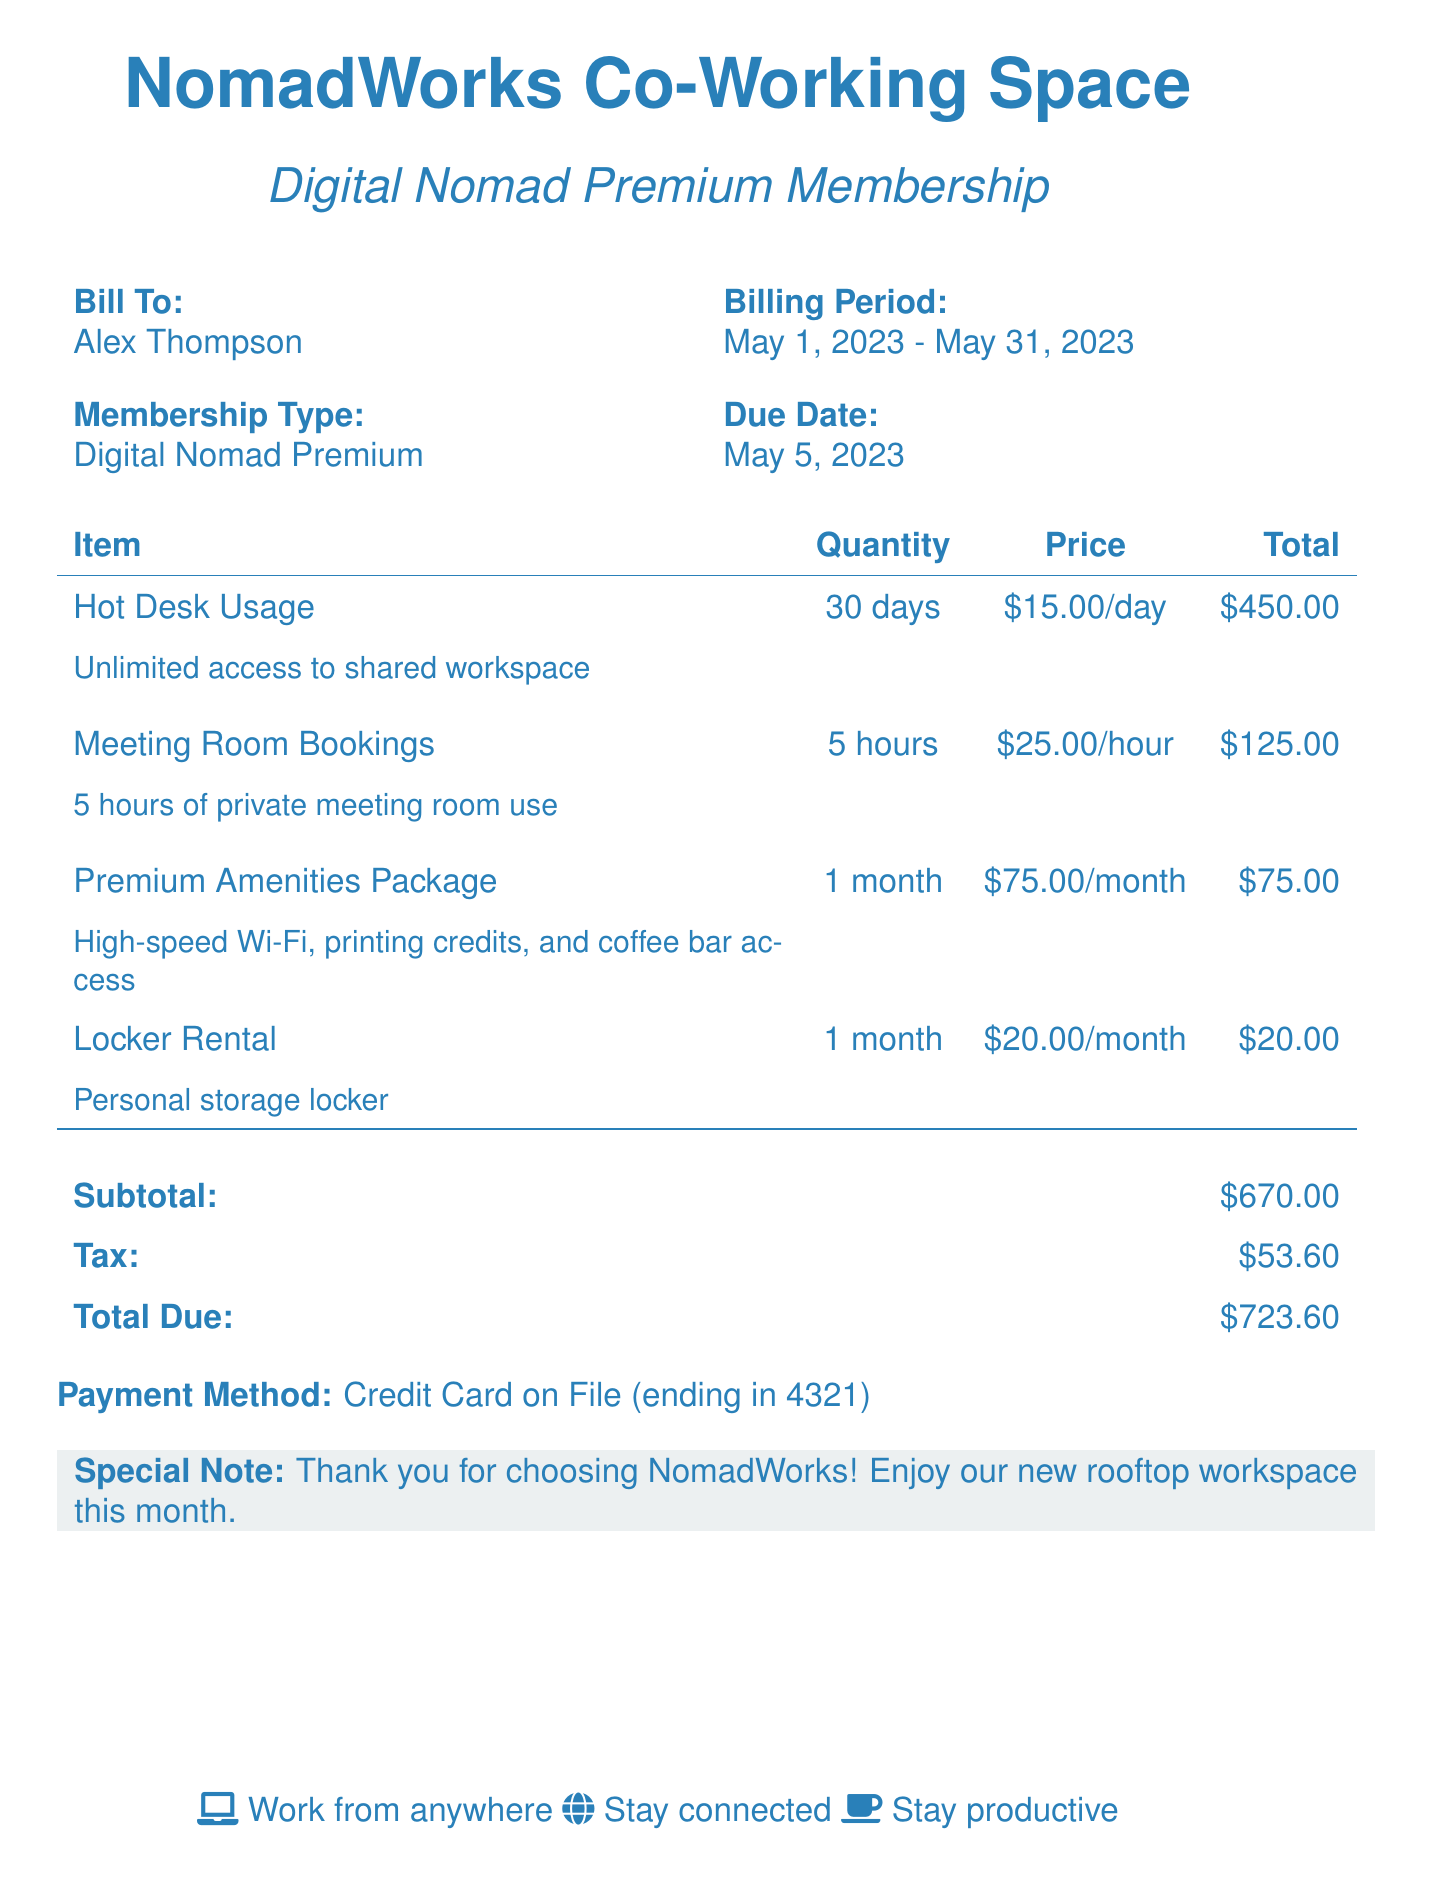What is the name of the co-working space? The document provides the name of the co-working space, which is listed at the top.
Answer: NomadWorks Co-Working Space What is the membership type? The membership type is mentioned in the document under the membership section.
Answer: Digital Nomad Premium What is the billing period? The billing period is specified in the document, indicating when the charges apply.
Answer: May 1, 2023 - May 31, 2023 How many days of hot desk usage are charged? The document shows the quantity of hot desk usage included in the bill.
Answer: 30 days What is the total due amount? The total due amount is provided at the bottom of the bill along with the subtotal and tax.
Answer: $723.60 What is the price per hour for meeting room bookings? The price for meeting room bookings is listed next to that line item in the document.
Answer: $25.00/hour How many hours of meeting room bookings are included? The document specifies the quantity of meeting room usage included in the bill.
Answer: 5 hours What is included in the Premium Amenities Package? The document briefly describes the services included in the Premium Amenities Package.
Answer: High-speed Wi-Fi, printing credits, and coffee bar access What is the due date for the payment? The due date for the payment is mentioned in the billing details section of the document.
Answer: May 5, 2023 